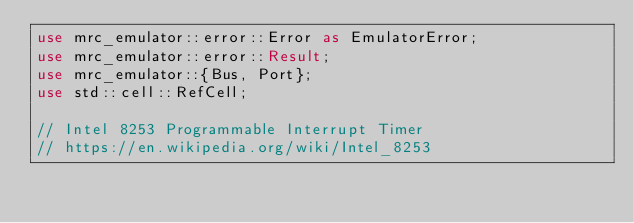Convert code to text. <code><loc_0><loc_0><loc_500><loc_500><_Rust_>use mrc_emulator::error::Error as EmulatorError;
use mrc_emulator::error::Result;
use mrc_emulator::{Bus, Port};
use std::cell::RefCell;

// Intel 8253 Programmable Interrupt Timer
// https://en.wikipedia.org/wiki/Intel_8253
</code> 